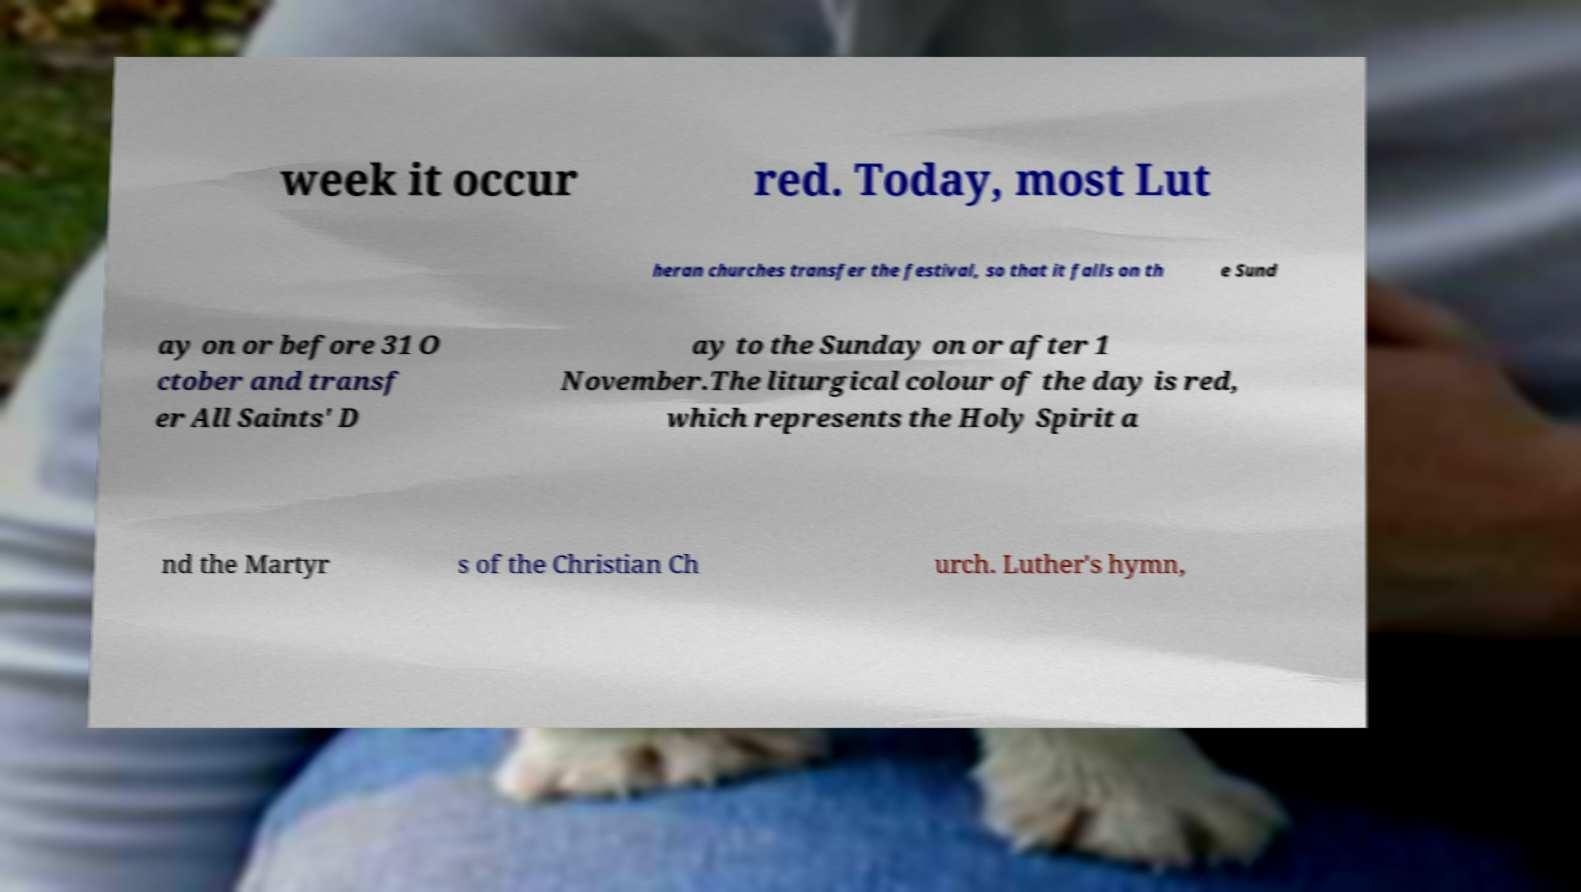Please identify and transcribe the text found in this image. week it occur red. Today, most Lut heran churches transfer the festival, so that it falls on th e Sund ay on or before 31 O ctober and transf er All Saints' D ay to the Sunday on or after 1 November.The liturgical colour of the day is red, which represents the Holy Spirit a nd the Martyr s of the Christian Ch urch. Luther's hymn, 